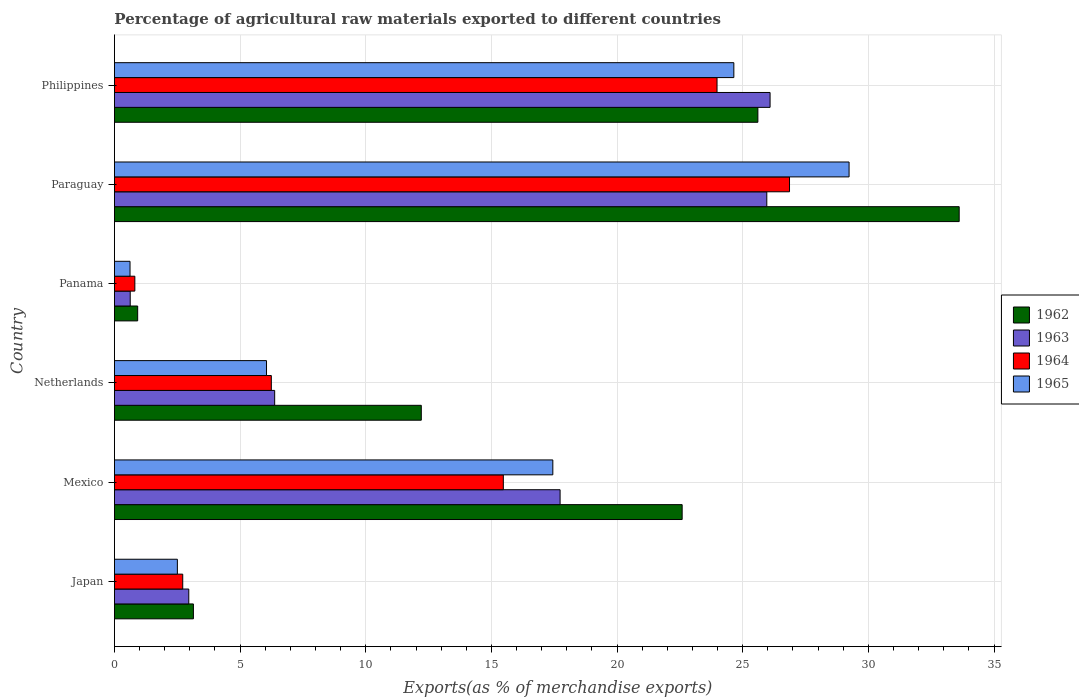How many different coloured bars are there?
Ensure brevity in your answer.  4. How many groups of bars are there?
Your response must be concise. 6. How many bars are there on the 1st tick from the bottom?
Offer a terse response. 4. In how many cases, is the number of bars for a given country not equal to the number of legend labels?
Provide a short and direct response. 0. What is the percentage of exports to different countries in 1963 in Philippines?
Make the answer very short. 26.09. Across all countries, what is the maximum percentage of exports to different countries in 1964?
Your response must be concise. 26.86. Across all countries, what is the minimum percentage of exports to different countries in 1964?
Offer a terse response. 0.81. In which country was the percentage of exports to different countries in 1965 maximum?
Give a very brief answer. Paraguay. In which country was the percentage of exports to different countries in 1965 minimum?
Provide a short and direct response. Panama. What is the total percentage of exports to different countries in 1964 in the graph?
Offer a terse response. 76.09. What is the difference between the percentage of exports to different countries in 1964 in Mexico and that in Netherlands?
Give a very brief answer. 9.23. What is the difference between the percentage of exports to different countries in 1965 in Japan and the percentage of exports to different countries in 1964 in Netherlands?
Your answer should be very brief. -3.74. What is the average percentage of exports to different countries in 1962 per country?
Offer a terse response. 16.35. What is the difference between the percentage of exports to different countries in 1963 and percentage of exports to different countries in 1962 in Japan?
Ensure brevity in your answer.  -0.18. What is the ratio of the percentage of exports to different countries in 1965 in Japan to that in Paraguay?
Provide a short and direct response. 0.09. Is the percentage of exports to different countries in 1965 in Mexico less than that in Panama?
Provide a short and direct response. No. What is the difference between the highest and the second highest percentage of exports to different countries in 1963?
Make the answer very short. 0.13. What is the difference between the highest and the lowest percentage of exports to different countries in 1964?
Offer a very short reply. 26.05. In how many countries, is the percentage of exports to different countries in 1965 greater than the average percentage of exports to different countries in 1965 taken over all countries?
Give a very brief answer. 3. Is it the case that in every country, the sum of the percentage of exports to different countries in 1965 and percentage of exports to different countries in 1964 is greater than the sum of percentage of exports to different countries in 1963 and percentage of exports to different countries in 1962?
Ensure brevity in your answer.  No. What does the 4th bar from the bottom in Mexico represents?
Provide a succinct answer. 1965. Is it the case that in every country, the sum of the percentage of exports to different countries in 1964 and percentage of exports to different countries in 1963 is greater than the percentage of exports to different countries in 1965?
Offer a terse response. Yes. How many bars are there?
Give a very brief answer. 24. How many countries are there in the graph?
Your answer should be very brief. 6. Are the values on the major ticks of X-axis written in scientific E-notation?
Make the answer very short. No. What is the title of the graph?
Offer a terse response. Percentage of agricultural raw materials exported to different countries. Does "2014" appear as one of the legend labels in the graph?
Provide a short and direct response. No. What is the label or title of the X-axis?
Ensure brevity in your answer.  Exports(as % of merchandise exports). What is the Exports(as % of merchandise exports) of 1962 in Japan?
Provide a short and direct response. 3.14. What is the Exports(as % of merchandise exports) of 1963 in Japan?
Provide a short and direct response. 2.96. What is the Exports(as % of merchandise exports) of 1964 in Japan?
Keep it short and to the point. 2.72. What is the Exports(as % of merchandise exports) in 1965 in Japan?
Offer a very short reply. 2.5. What is the Exports(as % of merchandise exports) in 1962 in Mexico?
Offer a terse response. 22.59. What is the Exports(as % of merchandise exports) in 1963 in Mexico?
Your answer should be very brief. 17.73. What is the Exports(as % of merchandise exports) in 1964 in Mexico?
Ensure brevity in your answer.  15.48. What is the Exports(as % of merchandise exports) in 1965 in Mexico?
Offer a very short reply. 17.44. What is the Exports(as % of merchandise exports) of 1962 in Netherlands?
Your answer should be compact. 12.21. What is the Exports(as % of merchandise exports) in 1963 in Netherlands?
Your response must be concise. 6.38. What is the Exports(as % of merchandise exports) in 1964 in Netherlands?
Provide a short and direct response. 6.24. What is the Exports(as % of merchandise exports) of 1965 in Netherlands?
Provide a short and direct response. 6.05. What is the Exports(as % of merchandise exports) of 1962 in Panama?
Your answer should be very brief. 0.92. What is the Exports(as % of merchandise exports) in 1963 in Panama?
Offer a terse response. 0.63. What is the Exports(as % of merchandise exports) in 1964 in Panama?
Provide a short and direct response. 0.81. What is the Exports(as % of merchandise exports) of 1965 in Panama?
Provide a succinct answer. 0.62. What is the Exports(as % of merchandise exports) in 1962 in Paraguay?
Offer a very short reply. 33.61. What is the Exports(as % of merchandise exports) in 1963 in Paraguay?
Offer a very short reply. 25.96. What is the Exports(as % of merchandise exports) in 1964 in Paraguay?
Your answer should be compact. 26.86. What is the Exports(as % of merchandise exports) of 1965 in Paraguay?
Give a very brief answer. 29.23. What is the Exports(as % of merchandise exports) of 1962 in Philippines?
Your answer should be very brief. 25.6. What is the Exports(as % of merchandise exports) in 1963 in Philippines?
Your answer should be very brief. 26.09. What is the Exports(as % of merchandise exports) of 1964 in Philippines?
Provide a short and direct response. 23.98. What is the Exports(as % of merchandise exports) of 1965 in Philippines?
Your answer should be very brief. 24.65. Across all countries, what is the maximum Exports(as % of merchandise exports) of 1962?
Ensure brevity in your answer.  33.61. Across all countries, what is the maximum Exports(as % of merchandise exports) of 1963?
Offer a very short reply. 26.09. Across all countries, what is the maximum Exports(as % of merchandise exports) of 1964?
Make the answer very short. 26.86. Across all countries, what is the maximum Exports(as % of merchandise exports) in 1965?
Give a very brief answer. 29.23. Across all countries, what is the minimum Exports(as % of merchandise exports) of 1962?
Keep it short and to the point. 0.92. Across all countries, what is the minimum Exports(as % of merchandise exports) in 1963?
Provide a succinct answer. 0.63. Across all countries, what is the minimum Exports(as % of merchandise exports) in 1964?
Offer a terse response. 0.81. Across all countries, what is the minimum Exports(as % of merchandise exports) of 1965?
Your response must be concise. 0.62. What is the total Exports(as % of merchandise exports) in 1962 in the graph?
Give a very brief answer. 98.09. What is the total Exports(as % of merchandise exports) in 1963 in the graph?
Your answer should be very brief. 79.74. What is the total Exports(as % of merchandise exports) of 1964 in the graph?
Your answer should be compact. 76.09. What is the total Exports(as % of merchandise exports) of 1965 in the graph?
Offer a very short reply. 80.5. What is the difference between the Exports(as % of merchandise exports) in 1962 in Japan and that in Mexico?
Ensure brevity in your answer.  -19.45. What is the difference between the Exports(as % of merchandise exports) in 1963 in Japan and that in Mexico?
Offer a terse response. -14.78. What is the difference between the Exports(as % of merchandise exports) in 1964 in Japan and that in Mexico?
Your answer should be compact. -12.76. What is the difference between the Exports(as % of merchandise exports) in 1965 in Japan and that in Mexico?
Your answer should be very brief. -14.94. What is the difference between the Exports(as % of merchandise exports) of 1962 in Japan and that in Netherlands?
Offer a terse response. -9.07. What is the difference between the Exports(as % of merchandise exports) of 1963 in Japan and that in Netherlands?
Make the answer very short. -3.42. What is the difference between the Exports(as % of merchandise exports) of 1964 in Japan and that in Netherlands?
Give a very brief answer. -3.53. What is the difference between the Exports(as % of merchandise exports) in 1965 in Japan and that in Netherlands?
Your response must be concise. -3.55. What is the difference between the Exports(as % of merchandise exports) of 1962 in Japan and that in Panama?
Ensure brevity in your answer.  2.22. What is the difference between the Exports(as % of merchandise exports) of 1963 in Japan and that in Panama?
Your answer should be very brief. 2.33. What is the difference between the Exports(as % of merchandise exports) in 1964 in Japan and that in Panama?
Your answer should be compact. 1.91. What is the difference between the Exports(as % of merchandise exports) of 1965 in Japan and that in Panama?
Offer a very short reply. 1.88. What is the difference between the Exports(as % of merchandise exports) in 1962 in Japan and that in Paraguay?
Make the answer very short. -30.47. What is the difference between the Exports(as % of merchandise exports) of 1963 in Japan and that in Paraguay?
Ensure brevity in your answer.  -23. What is the difference between the Exports(as % of merchandise exports) in 1964 in Japan and that in Paraguay?
Provide a short and direct response. -24.14. What is the difference between the Exports(as % of merchandise exports) of 1965 in Japan and that in Paraguay?
Make the answer very short. -26.73. What is the difference between the Exports(as % of merchandise exports) of 1962 in Japan and that in Philippines?
Keep it short and to the point. -22.46. What is the difference between the Exports(as % of merchandise exports) of 1963 in Japan and that in Philippines?
Keep it short and to the point. -23.13. What is the difference between the Exports(as % of merchandise exports) of 1964 in Japan and that in Philippines?
Your answer should be compact. -21.26. What is the difference between the Exports(as % of merchandise exports) in 1965 in Japan and that in Philippines?
Provide a succinct answer. -22.14. What is the difference between the Exports(as % of merchandise exports) in 1962 in Mexico and that in Netherlands?
Your answer should be very brief. 10.38. What is the difference between the Exports(as % of merchandise exports) of 1963 in Mexico and that in Netherlands?
Keep it short and to the point. 11.36. What is the difference between the Exports(as % of merchandise exports) in 1964 in Mexico and that in Netherlands?
Provide a succinct answer. 9.23. What is the difference between the Exports(as % of merchandise exports) in 1965 in Mexico and that in Netherlands?
Provide a short and direct response. 11.39. What is the difference between the Exports(as % of merchandise exports) of 1962 in Mexico and that in Panama?
Your answer should be compact. 21.67. What is the difference between the Exports(as % of merchandise exports) in 1963 in Mexico and that in Panama?
Keep it short and to the point. 17.11. What is the difference between the Exports(as % of merchandise exports) in 1964 in Mexico and that in Panama?
Make the answer very short. 14.66. What is the difference between the Exports(as % of merchandise exports) of 1965 in Mexico and that in Panama?
Your response must be concise. 16.82. What is the difference between the Exports(as % of merchandise exports) of 1962 in Mexico and that in Paraguay?
Ensure brevity in your answer.  -11.02. What is the difference between the Exports(as % of merchandise exports) of 1963 in Mexico and that in Paraguay?
Ensure brevity in your answer.  -8.23. What is the difference between the Exports(as % of merchandise exports) in 1964 in Mexico and that in Paraguay?
Provide a short and direct response. -11.39. What is the difference between the Exports(as % of merchandise exports) in 1965 in Mexico and that in Paraguay?
Your answer should be very brief. -11.79. What is the difference between the Exports(as % of merchandise exports) of 1962 in Mexico and that in Philippines?
Provide a short and direct response. -3.01. What is the difference between the Exports(as % of merchandise exports) of 1963 in Mexico and that in Philippines?
Your response must be concise. -8.36. What is the difference between the Exports(as % of merchandise exports) in 1964 in Mexico and that in Philippines?
Make the answer very short. -8.5. What is the difference between the Exports(as % of merchandise exports) in 1965 in Mexico and that in Philippines?
Provide a succinct answer. -7.2. What is the difference between the Exports(as % of merchandise exports) of 1962 in Netherlands and that in Panama?
Your answer should be compact. 11.29. What is the difference between the Exports(as % of merchandise exports) in 1963 in Netherlands and that in Panama?
Give a very brief answer. 5.75. What is the difference between the Exports(as % of merchandise exports) of 1964 in Netherlands and that in Panama?
Make the answer very short. 5.43. What is the difference between the Exports(as % of merchandise exports) of 1965 in Netherlands and that in Panama?
Offer a terse response. 5.43. What is the difference between the Exports(as % of merchandise exports) of 1962 in Netherlands and that in Paraguay?
Keep it short and to the point. -21.4. What is the difference between the Exports(as % of merchandise exports) of 1963 in Netherlands and that in Paraguay?
Keep it short and to the point. -19.58. What is the difference between the Exports(as % of merchandise exports) in 1964 in Netherlands and that in Paraguay?
Ensure brevity in your answer.  -20.62. What is the difference between the Exports(as % of merchandise exports) of 1965 in Netherlands and that in Paraguay?
Your answer should be compact. -23.18. What is the difference between the Exports(as % of merchandise exports) in 1962 in Netherlands and that in Philippines?
Ensure brevity in your answer.  -13.39. What is the difference between the Exports(as % of merchandise exports) of 1963 in Netherlands and that in Philippines?
Make the answer very short. -19.71. What is the difference between the Exports(as % of merchandise exports) in 1964 in Netherlands and that in Philippines?
Provide a short and direct response. -17.74. What is the difference between the Exports(as % of merchandise exports) in 1965 in Netherlands and that in Philippines?
Ensure brevity in your answer.  -18.6. What is the difference between the Exports(as % of merchandise exports) in 1962 in Panama and that in Paraguay?
Give a very brief answer. -32.69. What is the difference between the Exports(as % of merchandise exports) of 1963 in Panama and that in Paraguay?
Offer a very short reply. -25.33. What is the difference between the Exports(as % of merchandise exports) of 1964 in Panama and that in Paraguay?
Give a very brief answer. -26.05. What is the difference between the Exports(as % of merchandise exports) of 1965 in Panama and that in Paraguay?
Ensure brevity in your answer.  -28.61. What is the difference between the Exports(as % of merchandise exports) in 1962 in Panama and that in Philippines?
Provide a short and direct response. -24.68. What is the difference between the Exports(as % of merchandise exports) in 1963 in Panama and that in Philippines?
Your response must be concise. -25.46. What is the difference between the Exports(as % of merchandise exports) of 1964 in Panama and that in Philippines?
Provide a short and direct response. -23.17. What is the difference between the Exports(as % of merchandise exports) of 1965 in Panama and that in Philippines?
Your answer should be very brief. -24.03. What is the difference between the Exports(as % of merchandise exports) of 1962 in Paraguay and that in Philippines?
Make the answer very short. 8.01. What is the difference between the Exports(as % of merchandise exports) of 1963 in Paraguay and that in Philippines?
Provide a short and direct response. -0.13. What is the difference between the Exports(as % of merchandise exports) in 1964 in Paraguay and that in Philippines?
Provide a short and direct response. 2.88. What is the difference between the Exports(as % of merchandise exports) of 1965 in Paraguay and that in Philippines?
Offer a very short reply. 4.59. What is the difference between the Exports(as % of merchandise exports) in 1962 in Japan and the Exports(as % of merchandise exports) in 1963 in Mexico?
Keep it short and to the point. -14.59. What is the difference between the Exports(as % of merchandise exports) of 1962 in Japan and the Exports(as % of merchandise exports) of 1964 in Mexico?
Provide a succinct answer. -12.33. What is the difference between the Exports(as % of merchandise exports) of 1962 in Japan and the Exports(as % of merchandise exports) of 1965 in Mexico?
Ensure brevity in your answer.  -14.3. What is the difference between the Exports(as % of merchandise exports) of 1963 in Japan and the Exports(as % of merchandise exports) of 1964 in Mexico?
Make the answer very short. -12.52. What is the difference between the Exports(as % of merchandise exports) of 1963 in Japan and the Exports(as % of merchandise exports) of 1965 in Mexico?
Your answer should be very brief. -14.49. What is the difference between the Exports(as % of merchandise exports) in 1964 in Japan and the Exports(as % of merchandise exports) in 1965 in Mexico?
Your response must be concise. -14.73. What is the difference between the Exports(as % of merchandise exports) in 1962 in Japan and the Exports(as % of merchandise exports) in 1963 in Netherlands?
Provide a short and direct response. -3.23. What is the difference between the Exports(as % of merchandise exports) in 1962 in Japan and the Exports(as % of merchandise exports) in 1964 in Netherlands?
Provide a succinct answer. -3.1. What is the difference between the Exports(as % of merchandise exports) of 1962 in Japan and the Exports(as % of merchandise exports) of 1965 in Netherlands?
Provide a succinct answer. -2.91. What is the difference between the Exports(as % of merchandise exports) of 1963 in Japan and the Exports(as % of merchandise exports) of 1964 in Netherlands?
Your answer should be compact. -3.28. What is the difference between the Exports(as % of merchandise exports) of 1963 in Japan and the Exports(as % of merchandise exports) of 1965 in Netherlands?
Your answer should be compact. -3.09. What is the difference between the Exports(as % of merchandise exports) in 1964 in Japan and the Exports(as % of merchandise exports) in 1965 in Netherlands?
Your response must be concise. -3.33. What is the difference between the Exports(as % of merchandise exports) in 1962 in Japan and the Exports(as % of merchandise exports) in 1963 in Panama?
Make the answer very short. 2.51. What is the difference between the Exports(as % of merchandise exports) of 1962 in Japan and the Exports(as % of merchandise exports) of 1964 in Panama?
Provide a short and direct response. 2.33. What is the difference between the Exports(as % of merchandise exports) in 1962 in Japan and the Exports(as % of merchandise exports) in 1965 in Panama?
Offer a very short reply. 2.52. What is the difference between the Exports(as % of merchandise exports) of 1963 in Japan and the Exports(as % of merchandise exports) of 1964 in Panama?
Make the answer very short. 2.15. What is the difference between the Exports(as % of merchandise exports) in 1963 in Japan and the Exports(as % of merchandise exports) in 1965 in Panama?
Your response must be concise. 2.34. What is the difference between the Exports(as % of merchandise exports) of 1964 in Japan and the Exports(as % of merchandise exports) of 1965 in Panama?
Offer a very short reply. 2.1. What is the difference between the Exports(as % of merchandise exports) of 1962 in Japan and the Exports(as % of merchandise exports) of 1963 in Paraguay?
Provide a short and direct response. -22.82. What is the difference between the Exports(as % of merchandise exports) of 1962 in Japan and the Exports(as % of merchandise exports) of 1964 in Paraguay?
Your answer should be compact. -23.72. What is the difference between the Exports(as % of merchandise exports) in 1962 in Japan and the Exports(as % of merchandise exports) in 1965 in Paraguay?
Provide a short and direct response. -26.09. What is the difference between the Exports(as % of merchandise exports) in 1963 in Japan and the Exports(as % of merchandise exports) in 1964 in Paraguay?
Your response must be concise. -23.9. What is the difference between the Exports(as % of merchandise exports) in 1963 in Japan and the Exports(as % of merchandise exports) in 1965 in Paraguay?
Provide a succinct answer. -26.27. What is the difference between the Exports(as % of merchandise exports) in 1964 in Japan and the Exports(as % of merchandise exports) in 1965 in Paraguay?
Offer a terse response. -26.52. What is the difference between the Exports(as % of merchandise exports) of 1962 in Japan and the Exports(as % of merchandise exports) of 1963 in Philippines?
Keep it short and to the point. -22.95. What is the difference between the Exports(as % of merchandise exports) of 1962 in Japan and the Exports(as % of merchandise exports) of 1964 in Philippines?
Provide a succinct answer. -20.84. What is the difference between the Exports(as % of merchandise exports) of 1962 in Japan and the Exports(as % of merchandise exports) of 1965 in Philippines?
Your response must be concise. -21.5. What is the difference between the Exports(as % of merchandise exports) in 1963 in Japan and the Exports(as % of merchandise exports) in 1964 in Philippines?
Make the answer very short. -21.02. What is the difference between the Exports(as % of merchandise exports) in 1963 in Japan and the Exports(as % of merchandise exports) in 1965 in Philippines?
Make the answer very short. -21.69. What is the difference between the Exports(as % of merchandise exports) of 1964 in Japan and the Exports(as % of merchandise exports) of 1965 in Philippines?
Your response must be concise. -21.93. What is the difference between the Exports(as % of merchandise exports) of 1962 in Mexico and the Exports(as % of merchandise exports) of 1963 in Netherlands?
Offer a terse response. 16.21. What is the difference between the Exports(as % of merchandise exports) of 1962 in Mexico and the Exports(as % of merchandise exports) of 1964 in Netherlands?
Offer a terse response. 16.35. What is the difference between the Exports(as % of merchandise exports) in 1962 in Mexico and the Exports(as % of merchandise exports) in 1965 in Netherlands?
Give a very brief answer. 16.54. What is the difference between the Exports(as % of merchandise exports) in 1963 in Mexico and the Exports(as % of merchandise exports) in 1964 in Netherlands?
Your answer should be very brief. 11.49. What is the difference between the Exports(as % of merchandise exports) in 1963 in Mexico and the Exports(as % of merchandise exports) in 1965 in Netherlands?
Give a very brief answer. 11.68. What is the difference between the Exports(as % of merchandise exports) of 1964 in Mexico and the Exports(as % of merchandise exports) of 1965 in Netherlands?
Give a very brief answer. 9.42. What is the difference between the Exports(as % of merchandise exports) of 1962 in Mexico and the Exports(as % of merchandise exports) of 1963 in Panama?
Provide a succinct answer. 21.96. What is the difference between the Exports(as % of merchandise exports) of 1962 in Mexico and the Exports(as % of merchandise exports) of 1964 in Panama?
Your answer should be very brief. 21.78. What is the difference between the Exports(as % of merchandise exports) in 1962 in Mexico and the Exports(as % of merchandise exports) in 1965 in Panama?
Your response must be concise. 21.97. What is the difference between the Exports(as % of merchandise exports) in 1963 in Mexico and the Exports(as % of merchandise exports) in 1964 in Panama?
Keep it short and to the point. 16.92. What is the difference between the Exports(as % of merchandise exports) of 1963 in Mexico and the Exports(as % of merchandise exports) of 1965 in Panama?
Keep it short and to the point. 17.11. What is the difference between the Exports(as % of merchandise exports) of 1964 in Mexico and the Exports(as % of merchandise exports) of 1965 in Panama?
Provide a succinct answer. 14.85. What is the difference between the Exports(as % of merchandise exports) of 1962 in Mexico and the Exports(as % of merchandise exports) of 1963 in Paraguay?
Your response must be concise. -3.37. What is the difference between the Exports(as % of merchandise exports) in 1962 in Mexico and the Exports(as % of merchandise exports) in 1964 in Paraguay?
Keep it short and to the point. -4.27. What is the difference between the Exports(as % of merchandise exports) of 1962 in Mexico and the Exports(as % of merchandise exports) of 1965 in Paraguay?
Provide a short and direct response. -6.64. What is the difference between the Exports(as % of merchandise exports) in 1963 in Mexico and the Exports(as % of merchandise exports) in 1964 in Paraguay?
Give a very brief answer. -9.13. What is the difference between the Exports(as % of merchandise exports) of 1963 in Mexico and the Exports(as % of merchandise exports) of 1965 in Paraguay?
Ensure brevity in your answer.  -11.5. What is the difference between the Exports(as % of merchandise exports) in 1964 in Mexico and the Exports(as % of merchandise exports) in 1965 in Paraguay?
Provide a short and direct response. -13.76. What is the difference between the Exports(as % of merchandise exports) in 1962 in Mexico and the Exports(as % of merchandise exports) in 1963 in Philippines?
Your response must be concise. -3.5. What is the difference between the Exports(as % of merchandise exports) in 1962 in Mexico and the Exports(as % of merchandise exports) in 1964 in Philippines?
Make the answer very short. -1.39. What is the difference between the Exports(as % of merchandise exports) of 1962 in Mexico and the Exports(as % of merchandise exports) of 1965 in Philippines?
Keep it short and to the point. -2.06. What is the difference between the Exports(as % of merchandise exports) of 1963 in Mexico and the Exports(as % of merchandise exports) of 1964 in Philippines?
Make the answer very short. -6.25. What is the difference between the Exports(as % of merchandise exports) in 1963 in Mexico and the Exports(as % of merchandise exports) in 1965 in Philippines?
Make the answer very short. -6.91. What is the difference between the Exports(as % of merchandise exports) in 1964 in Mexico and the Exports(as % of merchandise exports) in 1965 in Philippines?
Your response must be concise. -9.17. What is the difference between the Exports(as % of merchandise exports) of 1962 in Netherlands and the Exports(as % of merchandise exports) of 1963 in Panama?
Give a very brief answer. 11.58. What is the difference between the Exports(as % of merchandise exports) of 1962 in Netherlands and the Exports(as % of merchandise exports) of 1964 in Panama?
Your response must be concise. 11.4. What is the difference between the Exports(as % of merchandise exports) in 1962 in Netherlands and the Exports(as % of merchandise exports) in 1965 in Panama?
Provide a succinct answer. 11.59. What is the difference between the Exports(as % of merchandise exports) of 1963 in Netherlands and the Exports(as % of merchandise exports) of 1964 in Panama?
Keep it short and to the point. 5.56. What is the difference between the Exports(as % of merchandise exports) in 1963 in Netherlands and the Exports(as % of merchandise exports) in 1965 in Panama?
Offer a very short reply. 5.76. What is the difference between the Exports(as % of merchandise exports) in 1964 in Netherlands and the Exports(as % of merchandise exports) in 1965 in Panama?
Provide a succinct answer. 5.62. What is the difference between the Exports(as % of merchandise exports) of 1962 in Netherlands and the Exports(as % of merchandise exports) of 1963 in Paraguay?
Your response must be concise. -13.75. What is the difference between the Exports(as % of merchandise exports) of 1962 in Netherlands and the Exports(as % of merchandise exports) of 1964 in Paraguay?
Give a very brief answer. -14.65. What is the difference between the Exports(as % of merchandise exports) of 1962 in Netherlands and the Exports(as % of merchandise exports) of 1965 in Paraguay?
Your response must be concise. -17.02. What is the difference between the Exports(as % of merchandise exports) of 1963 in Netherlands and the Exports(as % of merchandise exports) of 1964 in Paraguay?
Your response must be concise. -20.49. What is the difference between the Exports(as % of merchandise exports) in 1963 in Netherlands and the Exports(as % of merchandise exports) in 1965 in Paraguay?
Ensure brevity in your answer.  -22.86. What is the difference between the Exports(as % of merchandise exports) of 1964 in Netherlands and the Exports(as % of merchandise exports) of 1965 in Paraguay?
Your response must be concise. -22.99. What is the difference between the Exports(as % of merchandise exports) of 1962 in Netherlands and the Exports(as % of merchandise exports) of 1963 in Philippines?
Provide a short and direct response. -13.88. What is the difference between the Exports(as % of merchandise exports) in 1962 in Netherlands and the Exports(as % of merchandise exports) in 1964 in Philippines?
Offer a terse response. -11.77. What is the difference between the Exports(as % of merchandise exports) in 1962 in Netherlands and the Exports(as % of merchandise exports) in 1965 in Philippines?
Give a very brief answer. -12.44. What is the difference between the Exports(as % of merchandise exports) of 1963 in Netherlands and the Exports(as % of merchandise exports) of 1964 in Philippines?
Provide a succinct answer. -17.6. What is the difference between the Exports(as % of merchandise exports) in 1963 in Netherlands and the Exports(as % of merchandise exports) in 1965 in Philippines?
Your answer should be compact. -18.27. What is the difference between the Exports(as % of merchandise exports) in 1964 in Netherlands and the Exports(as % of merchandise exports) in 1965 in Philippines?
Your answer should be very brief. -18.4. What is the difference between the Exports(as % of merchandise exports) in 1962 in Panama and the Exports(as % of merchandise exports) in 1963 in Paraguay?
Offer a very short reply. -25.03. What is the difference between the Exports(as % of merchandise exports) of 1962 in Panama and the Exports(as % of merchandise exports) of 1964 in Paraguay?
Your answer should be compact. -25.94. What is the difference between the Exports(as % of merchandise exports) of 1962 in Panama and the Exports(as % of merchandise exports) of 1965 in Paraguay?
Provide a short and direct response. -28.31. What is the difference between the Exports(as % of merchandise exports) of 1963 in Panama and the Exports(as % of merchandise exports) of 1964 in Paraguay?
Your answer should be compact. -26.23. What is the difference between the Exports(as % of merchandise exports) of 1963 in Panama and the Exports(as % of merchandise exports) of 1965 in Paraguay?
Give a very brief answer. -28.6. What is the difference between the Exports(as % of merchandise exports) in 1964 in Panama and the Exports(as % of merchandise exports) in 1965 in Paraguay?
Provide a succinct answer. -28.42. What is the difference between the Exports(as % of merchandise exports) in 1962 in Panama and the Exports(as % of merchandise exports) in 1963 in Philippines?
Give a very brief answer. -25.16. What is the difference between the Exports(as % of merchandise exports) of 1962 in Panama and the Exports(as % of merchandise exports) of 1964 in Philippines?
Provide a short and direct response. -23.05. What is the difference between the Exports(as % of merchandise exports) in 1962 in Panama and the Exports(as % of merchandise exports) in 1965 in Philippines?
Your answer should be compact. -23.72. What is the difference between the Exports(as % of merchandise exports) of 1963 in Panama and the Exports(as % of merchandise exports) of 1964 in Philippines?
Give a very brief answer. -23.35. What is the difference between the Exports(as % of merchandise exports) of 1963 in Panama and the Exports(as % of merchandise exports) of 1965 in Philippines?
Make the answer very short. -24.02. What is the difference between the Exports(as % of merchandise exports) in 1964 in Panama and the Exports(as % of merchandise exports) in 1965 in Philippines?
Your response must be concise. -23.84. What is the difference between the Exports(as % of merchandise exports) in 1962 in Paraguay and the Exports(as % of merchandise exports) in 1963 in Philippines?
Keep it short and to the point. 7.53. What is the difference between the Exports(as % of merchandise exports) of 1962 in Paraguay and the Exports(as % of merchandise exports) of 1964 in Philippines?
Make the answer very short. 9.64. What is the difference between the Exports(as % of merchandise exports) in 1962 in Paraguay and the Exports(as % of merchandise exports) in 1965 in Philippines?
Provide a short and direct response. 8.97. What is the difference between the Exports(as % of merchandise exports) in 1963 in Paraguay and the Exports(as % of merchandise exports) in 1964 in Philippines?
Provide a short and direct response. 1.98. What is the difference between the Exports(as % of merchandise exports) in 1963 in Paraguay and the Exports(as % of merchandise exports) in 1965 in Philippines?
Provide a succinct answer. 1.31. What is the difference between the Exports(as % of merchandise exports) of 1964 in Paraguay and the Exports(as % of merchandise exports) of 1965 in Philippines?
Offer a very short reply. 2.22. What is the average Exports(as % of merchandise exports) of 1962 per country?
Offer a terse response. 16.35. What is the average Exports(as % of merchandise exports) of 1963 per country?
Give a very brief answer. 13.29. What is the average Exports(as % of merchandise exports) of 1964 per country?
Offer a very short reply. 12.68. What is the average Exports(as % of merchandise exports) of 1965 per country?
Provide a short and direct response. 13.42. What is the difference between the Exports(as % of merchandise exports) of 1962 and Exports(as % of merchandise exports) of 1963 in Japan?
Provide a succinct answer. 0.18. What is the difference between the Exports(as % of merchandise exports) in 1962 and Exports(as % of merchandise exports) in 1964 in Japan?
Provide a succinct answer. 0.42. What is the difference between the Exports(as % of merchandise exports) of 1962 and Exports(as % of merchandise exports) of 1965 in Japan?
Make the answer very short. 0.64. What is the difference between the Exports(as % of merchandise exports) in 1963 and Exports(as % of merchandise exports) in 1964 in Japan?
Your answer should be very brief. 0.24. What is the difference between the Exports(as % of merchandise exports) in 1963 and Exports(as % of merchandise exports) in 1965 in Japan?
Provide a succinct answer. 0.45. What is the difference between the Exports(as % of merchandise exports) of 1964 and Exports(as % of merchandise exports) of 1965 in Japan?
Provide a short and direct response. 0.21. What is the difference between the Exports(as % of merchandise exports) in 1962 and Exports(as % of merchandise exports) in 1963 in Mexico?
Offer a terse response. 4.86. What is the difference between the Exports(as % of merchandise exports) in 1962 and Exports(as % of merchandise exports) in 1964 in Mexico?
Provide a short and direct response. 7.12. What is the difference between the Exports(as % of merchandise exports) of 1962 and Exports(as % of merchandise exports) of 1965 in Mexico?
Provide a short and direct response. 5.15. What is the difference between the Exports(as % of merchandise exports) of 1963 and Exports(as % of merchandise exports) of 1964 in Mexico?
Your answer should be compact. 2.26. What is the difference between the Exports(as % of merchandise exports) in 1963 and Exports(as % of merchandise exports) in 1965 in Mexico?
Your answer should be compact. 0.29. What is the difference between the Exports(as % of merchandise exports) in 1964 and Exports(as % of merchandise exports) in 1965 in Mexico?
Provide a short and direct response. -1.97. What is the difference between the Exports(as % of merchandise exports) in 1962 and Exports(as % of merchandise exports) in 1963 in Netherlands?
Keep it short and to the point. 5.83. What is the difference between the Exports(as % of merchandise exports) in 1962 and Exports(as % of merchandise exports) in 1964 in Netherlands?
Give a very brief answer. 5.97. What is the difference between the Exports(as % of merchandise exports) of 1962 and Exports(as % of merchandise exports) of 1965 in Netherlands?
Provide a short and direct response. 6.16. What is the difference between the Exports(as % of merchandise exports) of 1963 and Exports(as % of merchandise exports) of 1964 in Netherlands?
Your response must be concise. 0.13. What is the difference between the Exports(as % of merchandise exports) in 1963 and Exports(as % of merchandise exports) in 1965 in Netherlands?
Make the answer very short. 0.32. What is the difference between the Exports(as % of merchandise exports) of 1964 and Exports(as % of merchandise exports) of 1965 in Netherlands?
Make the answer very short. 0.19. What is the difference between the Exports(as % of merchandise exports) of 1962 and Exports(as % of merchandise exports) of 1963 in Panama?
Offer a very short reply. 0.3. What is the difference between the Exports(as % of merchandise exports) of 1962 and Exports(as % of merchandise exports) of 1964 in Panama?
Make the answer very short. 0.11. What is the difference between the Exports(as % of merchandise exports) of 1962 and Exports(as % of merchandise exports) of 1965 in Panama?
Provide a short and direct response. 0.3. What is the difference between the Exports(as % of merchandise exports) of 1963 and Exports(as % of merchandise exports) of 1964 in Panama?
Your answer should be compact. -0.18. What is the difference between the Exports(as % of merchandise exports) of 1963 and Exports(as % of merchandise exports) of 1965 in Panama?
Your answer should be compact. 0.01. What is the difference between the Exports(as % of merchandise exports) of 1964 and Exports(as % of merchandise exports) of 1965 in Panama?
Your answer should be compact. 0.19. What is the difference between the Exports(as % of merchandise exports) in 1962 and Exports(as % of merchandise exports) in 1963 in Paraguay?
Make the answer very short. 7.66. What is the difference between the Exports(as % of merchandise exports) in 1962 and Exports(as % of merchandise exports) in 1964 in Paraguay?
Your answer should be very brief. 6.75. What is the difference between the Exports(as % of merchandise exports) in 1962 and Exports(as % of merchandise exports) in 1965 in Paraguay?
Provide a succinct answer. 4.38. What is the difference between the Exports(as % of merchandise exports) of 1963 and Exports(as % of merchandise exports) of 1964 in Paraguay?
Give a very brief answer. -0.9. What is the difference between the Exports(as % of merchandise exports) of 1963 and Exports(as % of merchandise exports) of 1965 in Paraguay?
Make the answer very short. -3.27. What is the difference between the Exports(as % of merchandise exports) of 1964 and Exports(as % of merchandise exports) of 1965 in Paraguay?
Make the answer very short. -2.37. What is the difference between the Exports(as % of merchandise exports) of 1962 and Exports(as % of merchandise exports) of 1963 in Philippines?
Offer a terse response. -0.49. What is the difference between the Exports(as % of merchandise exports) in 1962 and Exports(as % of merchandise exports) in 1964 in Philippines?
Provide a succinct answer. 1.63. What is the difference between the Exports(as % of merchandise exports) in 1962 and Exports(as % of merchandise exports) in 1965 in Philippines?
Make the answer very short. 0.96. What is the difference between the Exports(as % of merchandise exports) of 1963 and Exports(as % of merchandise exports) of 1964 in Philippines?
Provide a succinct answer. 2.11. What is the difference between the Exports(as % of merchandise exports) in 1963 and Exports(as % of merchandise exports) in 1965 in Philippines?
Make the answer very short. 1.44. What is the difference between the Exports(as % of merchandise exports) in 1964 and Exports(as % of merchandise exports) in 1965 in Philippines?
Make the answer very short. -0.67. What is the ratio of the Exports(as % of merchandise exports) in 1962 in Japan to that in Mexico?
Ensure brevity in your answer.  0.14. What is the ratio of the Exports(as % of merchandise exports) of 1963 in Japan to that in Mexico?
Make the answer very short. 0.17. What is the ratio of the Exports(as % of merchandise exports) in 1964 in Japan to that in Mexico?
Offer a terse response. 0.18. What is the ratio of the Exports(as % of merchandise exports) in 1965 in Japan to that in Mexico?
Your response must be concise. 0.14. What is the ratio of the Exports(as % of merchandise exports) in 1962 in Japan to that in Netherlands?
Your response must be concise. 0.26. What is the ratio of the Exports(as % of merchandise exports) in 1963 in Japan to that in Netherlands?
Provide a succinct answer. 0.46. What is the ratio of the Exports(as % of merchandise exports) in 1964 in Japan to that in Netherlands?
Provide a succinct answer. 0.44. What is the ratio of the Exports(as % of merchandise exports) in 1965 in Japan to that in Netherlands?
Your response must be concise. 0.41. What is the ratio of the Exports(as % of merchandise exports) of 1962 in Japan to that in Panama?
Your response must be concise. 3.4. What is the ratio of the Exports(as % of merchandise exports) in 1963 in Japan to that in Panama?
Your answer should be very brief. 4.71. What is the ratio of the Exports(as % of merchandise exports) in 1964 in Japan to that in Panama?
Your answer should be compact. 3.35. What is the ratio of the Exports(as % of merchandise exports) of 1965 in Japan to that in Panama?
Make the answer very short. 4.04. What is the ratio of the Exports(as % of merchandise exports) in 1962 in Japan to that in Paraguay?
Offer a very short reply. 0.09. What is the ratio of the Exports(as % of merchandise exports) of 1963 in Japan to that in Paraguay?
Your answer should be compact. 0.11. What is the ratio of the Exports(as % of merchandise exports) of 1964 in Japan to that in Paraguay?
Keep it short and to the point. 0.1. What is the ratio of the Exports(as % of merchandise exports) of 1965 in Japan to that in Paraguay?
Keep it short and to the point. 0.09. What is the ratio of the Exports(as % of merchandise exports) in 1962 in Japan to that in Philippines?
Offer a terse response. 0.12. What is the ratio of the Exports(as % of merchandise exports) in 1963 in Japan to that in Philippines?
Offer a very short reply. 0.11. What is the ratio of the Exports(as % of merchandise exports) in 1964 in Japan to that in Philippines?
Offer a very short reply. 0.11. What is the ratio of the Exports(as % of merchandise exports) of 1965 in Japan to that in Philippines?
Provide a succinct answer. 0.1. What is the ratio of the Exports(as % of merchandise exports) in 1962 in Mexico to that in Netherlands?
Offer a terse response. 1.85. What is the ratio of the Exports(as % of merchandise exports) of 1963 in Mexico to that in Netherlands?
Provide a succinct answer. 2.78. What is the ratio of the Exports(as % of merchandise exports) in 1964 in Mexico to that in Netherlands?
Offer a very short reply. 2.48. What is the ratio of the Exports(as % of merchandise exports) of 1965 in Mexico to that in Netherlands?
Keep it short and to the point. 2.88. What is the ratio of the Exports(as % of merchandise exports) of 1962 in Mexico to that in Panama?
Your answer should be compact. 24.43. What is the ratio of the Exports(as % of merchandise exports) of 1963 in Mexico to that in Panama?
Provide a short and direct response. 28.23. What is the ratio of the Exports(as % of merchandise exports) in 1964 in Mexico to that in Panama?
Give a very brief answer. 19.05. What is the ratio of the Exports(as % of merchandise exports) of 1965 in Mexico to that in Panama?
Give a very brief answer. 28.11. What is the ratio of the Exports(as % of merchandise exports) of 1962 in Mexico to that in Paraguay?
Provide a succinct answer. 0.67. What is the ratio of the Exports(as % of merchandise exports) of 1963 in Mexico to that in Paraguay?
Ensure brevity in your answer.  0.68. What is the ratio of the Exports(as % of merchandise exports) of 1964 in Mexico to that in Paraguay?
Offer a terse response. 0.58. What is the ratio of the Exports(as % of merchandise exports) of 1965 in Mexico to that in Paraguay?
Your answer should be very brief. 0.6. What is the ratio of the Exports(as % of merchandise exports) of 1962 in Mexico to that in Philippines?
Offer a very short reply. 0.88. What is the ratio of the Exports(as % of merchandise exports) of 1963 in Mexico to that in Philippines?
Your answer should be compact. 0.68. What is the ratio of the Exports(as % of merchandise exports) in 1964 in Mexico to that in Philippines?
Make the answer very short. 0.65. What is the ratio of the Exports(as % of merchandise exports) in 1965 in Mexico to that in Philippines?
Your answer should be very brief. 0.71. What is the ratio of the Exports(as % of merchandise exports) in 1962 in Netherlands to that in Panama?
Offer a terse response. 13.21. What is the ratio of the Exports(as % of merchandise exports) of 1963 in Netherlands to that in Panama?
Keep it short and to the point. 10.15. What is the ratio of the Exports(as % of merchandise exports) of 1964 in Netherlands to that in Panama?
Your answer should be compact. 7.69. What is the ratio of the Exports(as % of merchandise exports) of 1965 in Netherlands to that in Panama?
Your response must be concise. 9.75. What is the ratio of the Exports(as % of merchandise exports) in 1962 in Netherlands to that in Paraguay?
Ensure brevity in your answer.  0.36. What is the ratio of the Exports(as % of merchandise exports) in 1963 in Netherlands to that in Paraguay?
Your response must be concise. 0.25. What is the ratio of the Exports(as % of merchandise exports) in 1964 in Netherlands to that in Paraguay?
Give a very brief answer. 0.23. What is the ratio of the Exports(as % of merchandise exports) of 1965 in Netherlands to that in Paraguay?
Offer a terse response. 0.21. What is the ratio of the Exports(as % of merchandise exports) of 1962 in Netherlands to that in Philippines?
Provide a succinct answer. 0.48. What is the ratio of the Exports(as % of merchandise exports) of 1963 in Netherlands to that in Philippines?
Provide a short and direct response. 0.24. What is the ratio of the Exports(as % of merchandise exports) of 1964 in Netherlands to that in Philippines?
Ensure brevity in your answer.  0.26. What is the ratio of the Exports(as % of merchandise exports) of 1965 in Netherlands to that in Philippines?
Keep it short and to the point. 0.25. What is the ratio of the Exports(as % of merchandise exports) of 1962 in Panama to that in Paraguay?
Ensure brevity in your answer.  0.03. What is the ratio of the Exports(as % of merchandise exports) in 1963 in Panama to that in Paraguay?
Offer a terse response. 0.02. What is the ratio of the Exports(as % of merchandise exports) of 1964 in Panama to that in Paraguay?
Offer a very short reply. 0.03. What is the ratio of the Exports(as % of merchandise exports) in 1965 in Panama to that in Paraguay?
Your response must be concise. 0.02. What is the ratio of the Exports(as % of merchandise exports) in 1962 in Panama to that in Philippines?
Give a very brief answer. 0.04. What is the ratio of the Exports(as % of merchandise exports) of 1963 in Panama to that in Philippines?
Keep it short and to the point. 0.02. What is the ratio of the Exports(as % of merchandise exports) of 1964 in Panama to that in Philippines?
Make the answer very short. 0.03. What is the ratio of the Exports(as % of merchandise exports) in 1965 in Panama to that in Philippines?
Provide a succinct answer. 0.03. What is the ratio of the Exports(as % of merchandise exports) in 1962 in Paraguay to that in Philippines?
Offer a terse response. 1.31. What is the ratio of the Exports(as % of merchandise exports) of 1964 in Paraguay to that in Philippines?
Give a very brief answer. 1.12. What is the ratio of the Exports(as % of merchandise exports) of 1965 in Paraguay to that in Philippines?
Keep it short and to the point. 1.19. What is the difference between the highest and the second highest Exports(as % of merchandise exports) in 1962?
Your answer should be compact. 8.01. What is the difference between the highest and the second highest Exports(as % of merchandise exports) of 1963?
Offer a very short reply. 0.13. What is the difference between the highest and the second highest Exports(as % of merchandise exports) of 1964?
Make the answer very short. 2.88. What is the difference between the highest and the second highest Exports(as % of merchandise exports) in 1965?
Provide a short and direct response. 4.59. What is the difference between the highest and the lowest Exports(as % of merchandise exports) in 1962?
Your answer should be very brief. 32.69. What is the difference between the highest and the lowest Exports(as % of merchandise exports) in 1963?
Keep it short and to the point. 25.46. What is the difference between the highest and the lowest Exports(as % of merchandise exports) in 1964?
Your answer should be compact. 26.05. What is the difference between the highest and the lowest Exports(as % of merchandise exports) in 1965?
Give a very brief answer. 28.61. 